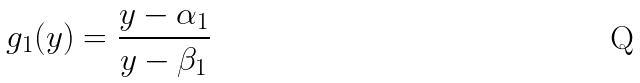Convert formula to latex. <formula><loc_0><loc_0><loc_500><loc_500>g _ { 1 } ( y ) = \frac { y - \alpha _ { 1 } } { y - \beta _ { 1 } }</formula> 